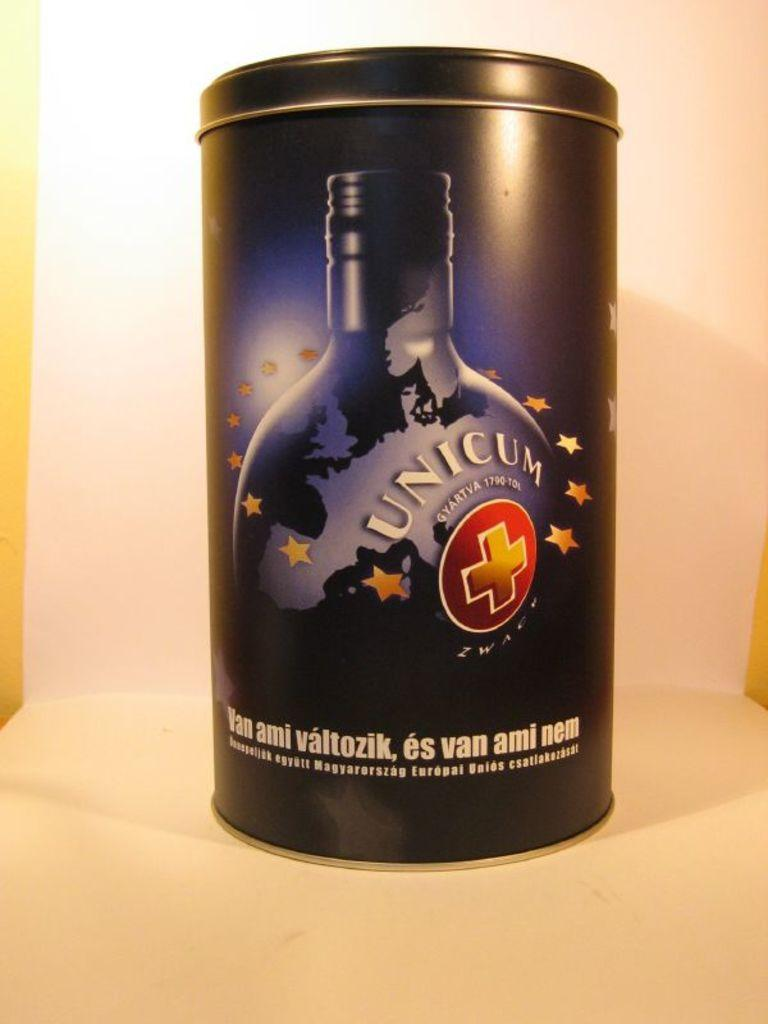<image>
Relay a brief, clear account of the picture shown. A blue and black metal tin with Unicum on it. 